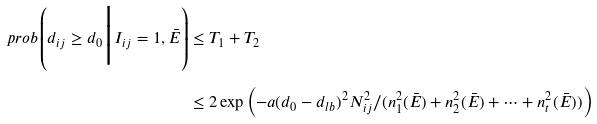<formula> <loc_0><loc_0><loc_500><loc_500>\ p r o b \left ( d _ { i j } \geq d _ { 0 } \Big | I _ { i j } = 1 , \bar { E } \right ) & \leq T _ { 1 } + T _ { 2 } \\ & \leq 2 \exp \left ( - a ( d _ { 0 } - d _ { l b } ) ^ { 2 } N _ { i j } ^ { 2 } / ( n _ { 1 } ^ { 2 } ( \bar { E } ) + n _ { 2 } ^ { 2 } ( \bar { E } ) + \dots + n _ { t } ^ { 2 } ( \bar { E } ) ) \right )</formula> 